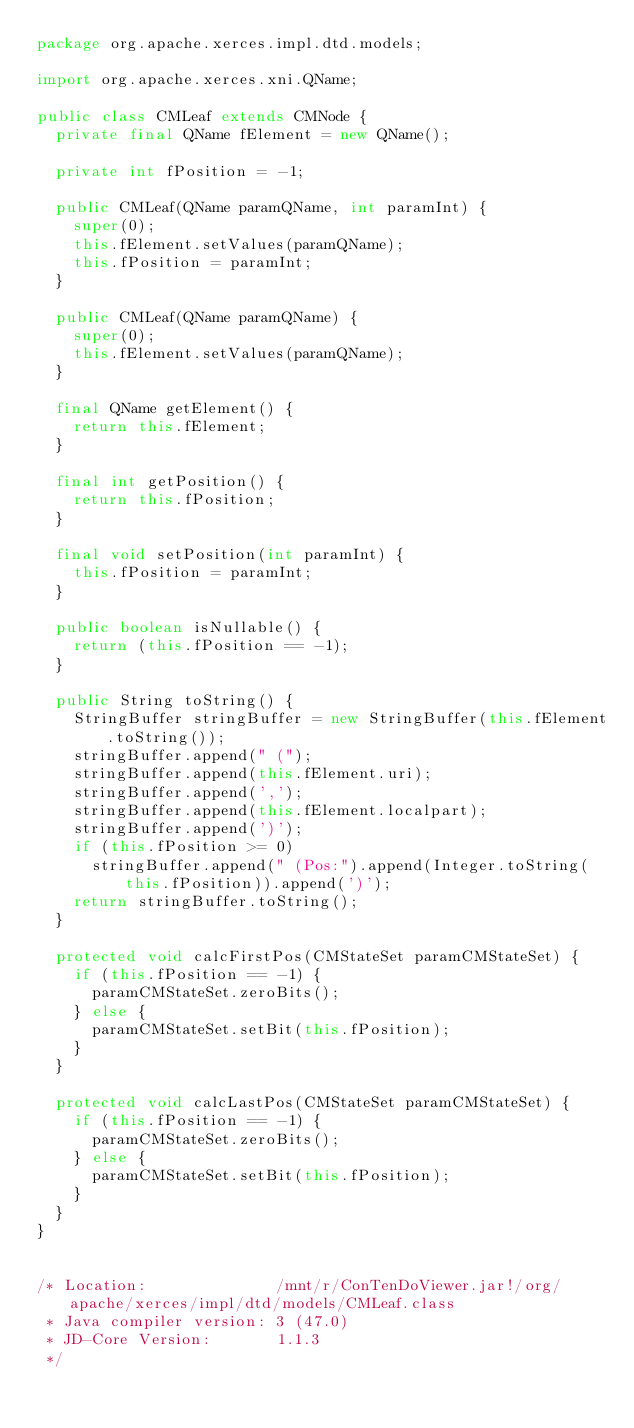<code> <loc_0><loc_0><loc_500><loc_500><_Java_>package org.apache.xerces.impl.dtd.models;

import org.apache.xerces.xni.QName;

public class CMLeaf extends CMNode {
  private final QName fElement = new QName();
  
  private int fPosition = -1;
  
  public CMLeaf(QName paramQName, int paramInt) {
    super(0);
    this.fElement.setValues(paramQName);
    this.fPosition = paramInt;
  }
  
  public CMLeaf(QName paramQName) {
    super(0);
    this.fElement.setValues(paramQName);
  }
  
  final QName getElement() {
    return this.fElement;
  }
  
  final int getPosition() {
    return this.fPosition;
  }
  
  final void setPosition(int paramInt) {
    this.fPosition = paramInt;
  }
  
  public boolean isNullable() {
    return (this.fPosition == -1);
  }
  
  public String toString() {
    StringBuffer stringBuffer = new StringBuffer(this.fElement.toString());
    stringBuffer.append(" (");
    stringBuffer.append(this.fElement.uri);
    stringBuffer.append(',');
    stringBuffer.append(this.fElement.localpart);
    stringBuffer.append(')');
    if (this.fPosition >= 0)
      stringBuffer.append(" (Pos:").append(Integer.toString(this.fPosition)).append(')'); 
    return stringBuffer.toString();
  }
  
  protected void calcFirstPos(CMStateSet paramCMStateSet) {
    if (this.fPosition == -1) {
      paramCMStateSet.zeroBits();
    } else {
      paramCMStateSet.setBit(this.fPosition);
    } 
  }
  
  protected void calcLastPos(CMStateSet paramCMStateSet) {
    if (this.fPosition == -1) {
      paramCMStateSet.zeroBits();
    } else {
      paramCMStateSet.setBit(this.fPosition);
    } 
  }
}


/* Location:              /mnt/r/ConTenDoViewer.jar!/org/apache/xerces/impl/dtd/models/CMLeaf.class
 * Java compiler version: 3 (47.0)
 * JD-Core Version:       1.1.3
 */</code> 